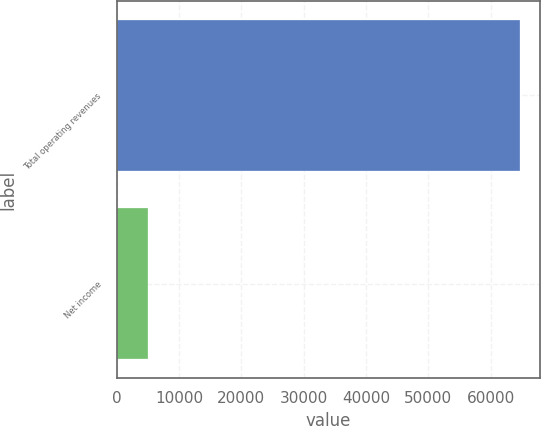Convert chart. <chart><loc_0><loc_0><loc_500><loc_500><bar_chart><fcel>Total operating revenues<fcel>Net income<nl><fcel>64708<fcel>5095<nl></chart> 